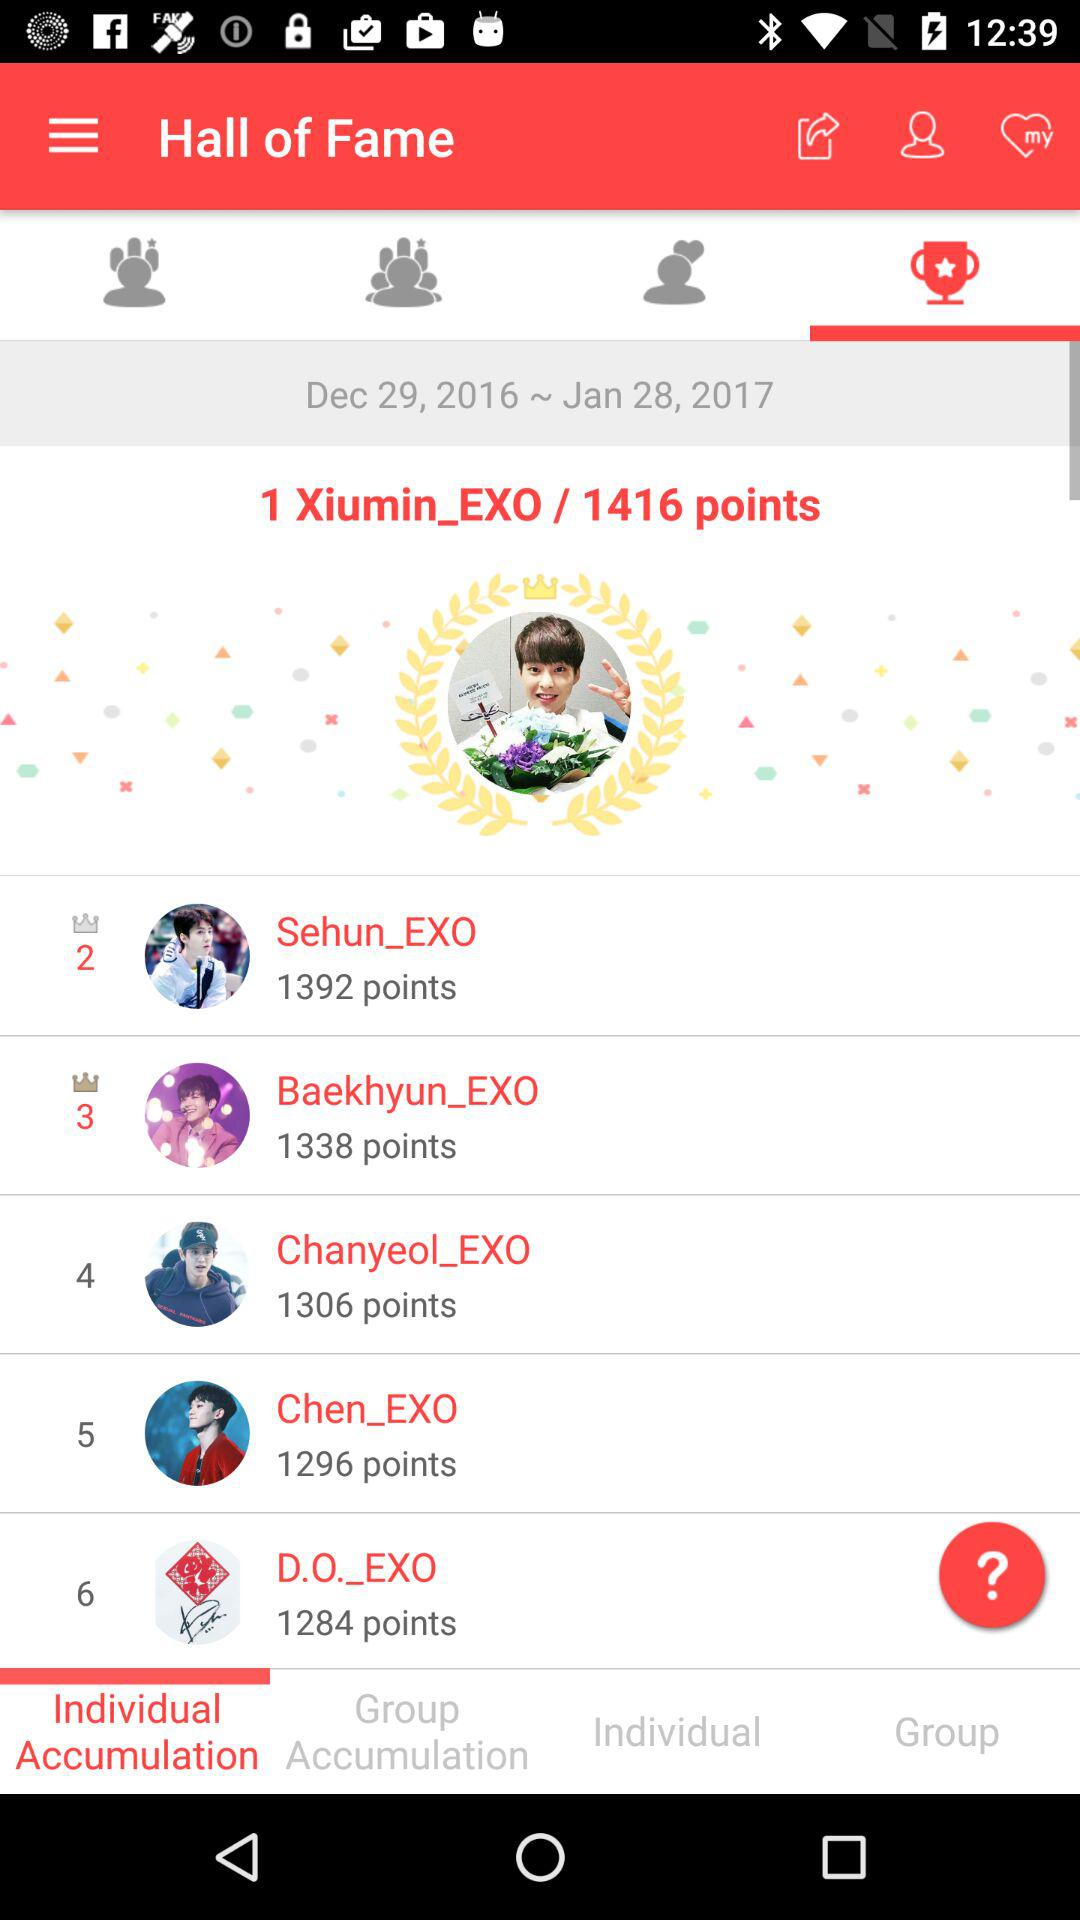Which tab is selected? The selected tabs are "Individual Accumulation" and "Hall of Fame". 